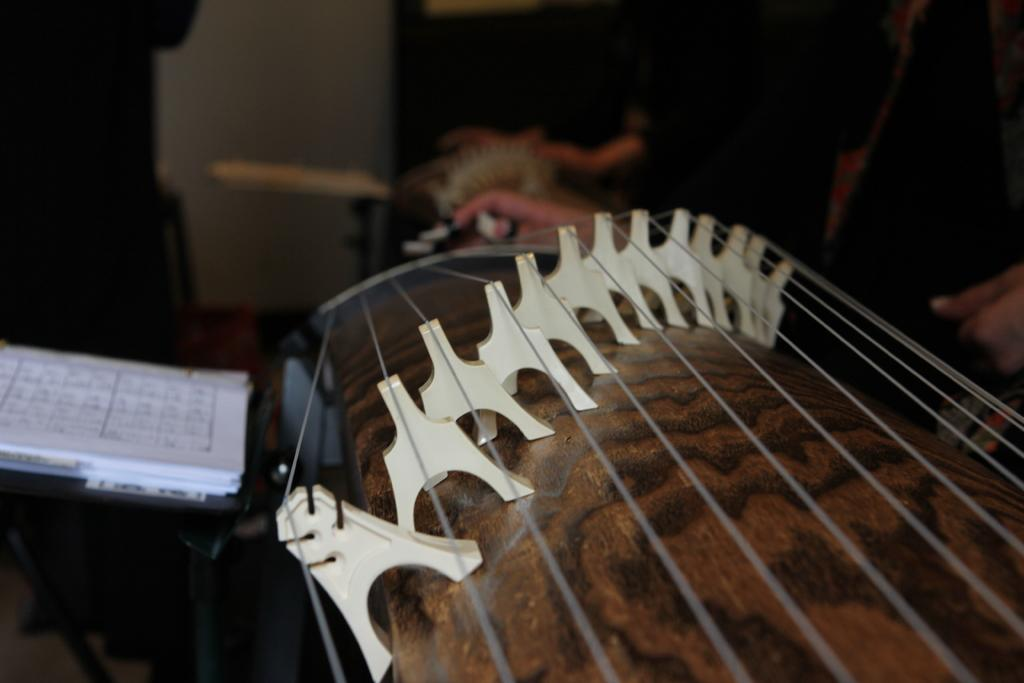What is the main subject in the center of the image? There is a book, a bag, and a musical instrument in the center of the image. Can you describe the objects in the center of the image? The book, bag, and musical instrument are all located in the center of the image. What can be seen in the background of the image? There is a wall and other objects visible in the background of the image. What type of voice can be heard singing from the musical instrument in the image? There is no voice or singing present in the image; it only shows a book, a bag, and a musical instrument in the center, and a wall and other objects in the background. 